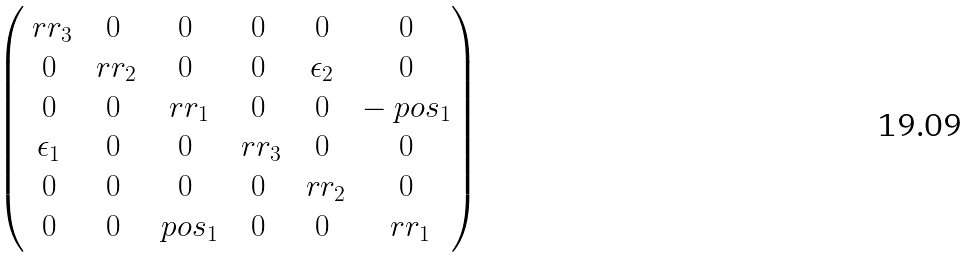Convert formula to latex. <formula><loc_0><loc_0><loc_500><loc_500>\begin{pmatrix} \ r r _ { 3 } & 0 & 0 & 0 & 0 & 0 \\ 0 & \ r r _ { 2 } & 0 & 0 & \epsilon _ { 2 } & 0 \\ 0 & 0 & \ r r _ { 1 } & 0 & 0 & - \ p o s _ { 1 } \\ \epsilon _ { 1 } & 0 & 0 & \ r r _ { 3 } & 0 & 0 \\ 0 & 0 & 0 & 0 & \ r r _ { 2 } & 0 \\ 0 & 0 & \ p o s _ { 1 } & 0 & 0 & \ r r _ { 1 } \end{pmatrix}</formula> 